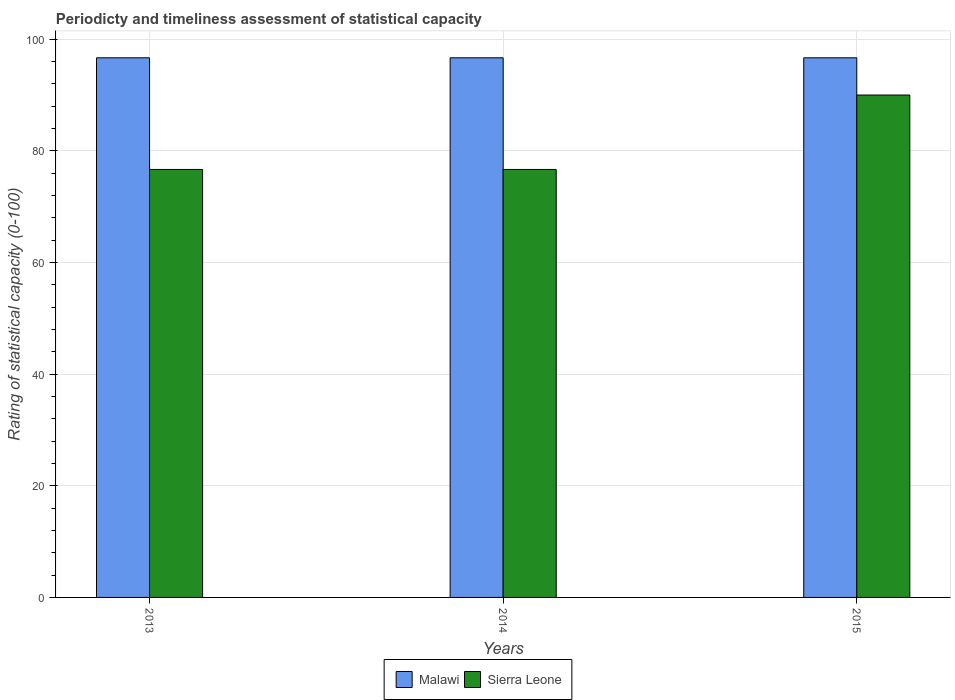How many different coloured bars are there?
Keep it short and to the point. 2. How many groups of bars are there?
Keep it short and to the point. 3. Are the number of bars per tick equal to the number of legend labels?
Give a very brief answer. Yes. Are the number of bars on each tick of the X-axis equal?
Give a very brief answer. Yes. How many bars are there on the 1st tick from the left?
Ensure brevity in your answer.  2. What is the label of the 3rd group of bars from the left?
Keep it short and to the point. 2015. In how many cases, is the number of bars for a given year not equal to the number of legend labels?
Offer a very short reply. 0. What is the rating of statistical capacity in Sierra Leone in 2014?
Your answer should be very brief. 76.67. Across all years, what is the maximum rating of statistical capacity in Malawi?
Provide a succinct answer. 96.67. Across all years, what is the minimum rating of statistical capacity in Malawi?
Your answer should be compact. 96.67. In which year was the rating of statistical capacity in Malawi maximum?
Ensure brevity in your answer.  2015. In which year was the rating of statistical capacity in Malawi minimum?
Offer a very short reply. 2013. What is the total rating of statistical capacity in Malawi in the graph?
Provide a succinct answer. 290. What is the difference between the rating of statistical capacity in Malawi in 2015 and the rating of statistical capacity in Sierra Leone in 2014?
Keep it short and to the point. 20. What is the average rating of statistical capacity in Malawi per year?
Your answer should be compact. 96.67. What is the ratio of the rating of statistical capacity in Sierra Leone in 2014 to that in 2015?
Ensure brevity in your answer.  0.85. What is the difference between the highest and the second highest rating of statistical capacity in Sierra Leone?
Your answer should be very brief. 13.33. What is the difference between the highest and the lowest rating of statistical capacity in Sierra Leone?
Offer a terse response. 13.33. In how many years, is the rating of statistical capacity in Sierra Leone greater than the average rating of statistical capacity in Sierra Leone taken over all years?
Give a very brief answer. 1. What does the 1st bar from the left in 2014 represents?
Offer a terse response. Malawi. What does the 2nd bar from the right in 2015 represents?
Keep it short and to the point. Malawi. How many bars are there?
Offer a terse response. 6. What is the difference between two consecutive major ticks on the Y-axis?
Provide a succinct answer. 20. Does the graph contain grids?
Offer a very short reply. Yes. What is the title of the graph?
Offer a very short reply. Periodicty and timeliness assessment of statistical capacity. Does "High income" appear as one of the legend labels in the graph?
Your answer should be very brief. No. What is the label or title of the Y-axis?
Give a very brief answer. Rating of statistical capacity (0-100). What is the Rating of statistical capacity (0-100) of Malawi in 2013?
Provide a succinct answer. 96.67. What is the Rating of statistical capacity (0-100) of Sierra Leone in 2013?
Ensure brevity in your answer.  76.67. What is the Rating of statistical capacity (0-100) in Malawi in 2014?
Give a very brief answer. 96.67. What is the Rating of statistical capacity (0-100) in Sierra Leone in 2014?
Provide a succinct answer. 76.67. What is the Rating of statistical capacity (0-100) in Malawi in 2015?
Offer a terse response. 96.67. What is the Rating of statistical capacity (0-100) of Sierra Leone in 2015?
Provide a short and direct response. 90. Across all years, what is the maximum Rating of statistical capacity (0-100) in Malawi?
Give a very brief answer. 96.67. Across all years, what is the maximum Rating of statistical capacity (0-100) of Sierra Leone?
Provide a succinct answer. 90. Across all years, what is the minimum Rating of statistical capacity (0-100) of Malawi?
Make the answer very short. 96.67. Across all years, what is the minimum Rating of statistical capacity (0-100) of Sierra Leone?
Offer a terse response. 76.67. What is the total Rating of statistical capacity (0-100) of Malawi in the graph?
Give a very brief answer. 290. What is the total Rating of statistical capacity (0-100) in Sierra Leone in the graph?
Offer a very short reply. 243.33. What is the difference between the Rating of statistical capacity (0-100) in Malawi in 2013 and that in 2015?
Provide a succinct answer. -0. What is the difference between the Rating of statistical capacity (0-100) in Sierra Leone in 2013 and that in 2015?
Your answer should be very brief. -13.33. What is the difference between the Rating of statistical capacity (0-100) of Sierra Leone in 2014 and that in 2015?
Your response must be concise. -13.33. What is the difference between the Rating of statistical capacity (0-100) of Malawi in 2013 and the Rating of statistical capacity (0-100) of Sierra Leone in 2014?
Your answer should be very brief. 20. What is the difference between the Rating of statistical capacity (0-100) of Malawi in 2013 and the Rating of statistical capacity (0-100) of Sierra Leone in 2015?
Make the answer very short. 6.67. What is the difference between the Rating of statistical capacity (0-100) in Malawi in 2014 and the Rating of statistical capacity (0-100) in Sierra Leone in 2015?
Offer a terse response. 6.67. What is the average Rating of statistical capacity (0-100) of Malawi per year?
Offer a terse response. 96.67. What is the average Rating of statistical capacity (0-100) in Sierra Leone per year?
Ensure brevity in your answer.  81.11. In the year 2013, what is the difference between the Rating of statistical capacity (0-100) in Malawi and Rating of statistical capacity (0-100) in Sierra Leone?
Provide a short and direct response. 20. In the year 2014, what is the difference between the Rating of statistical capacity (0-100) of Malawi and Rating of statistical capacity (0-100) of Sierra Leone?
Offer a very short reply. 20. In the year 2015, what is the difference between the Rating of statistical capacity (0-100) of Malawi and Rating of statistical capacity (0-100) of Sierra Leone?
Your answer should be compact. 6.67. What is the ratio of the Rating of statistical capacity (0-100) in Malawi in 2013 to that in 2014?
Give a very brief answer. 1. What is the ratio of the Rating of statistical capacity (0-100) in Sierra Leone in 2013 to that in 2015?
Ensure brevity in your answer.  0.85. What is the ratio of the Rating of statistical capacity (0-100) in Sierra Leone in 2014 to that in 2015?
Offer a very short reply. 0.85. What is the difference between the highest and the second highest Rating of statistical capacity (0-100) in Sierra Leone?
Give a very brief answer. 13.33. What is the difference between the highest and the lowest Rating of statistical capacity (0-100) of Sierra Leone?
Your answer should be very brief. 13.33. 